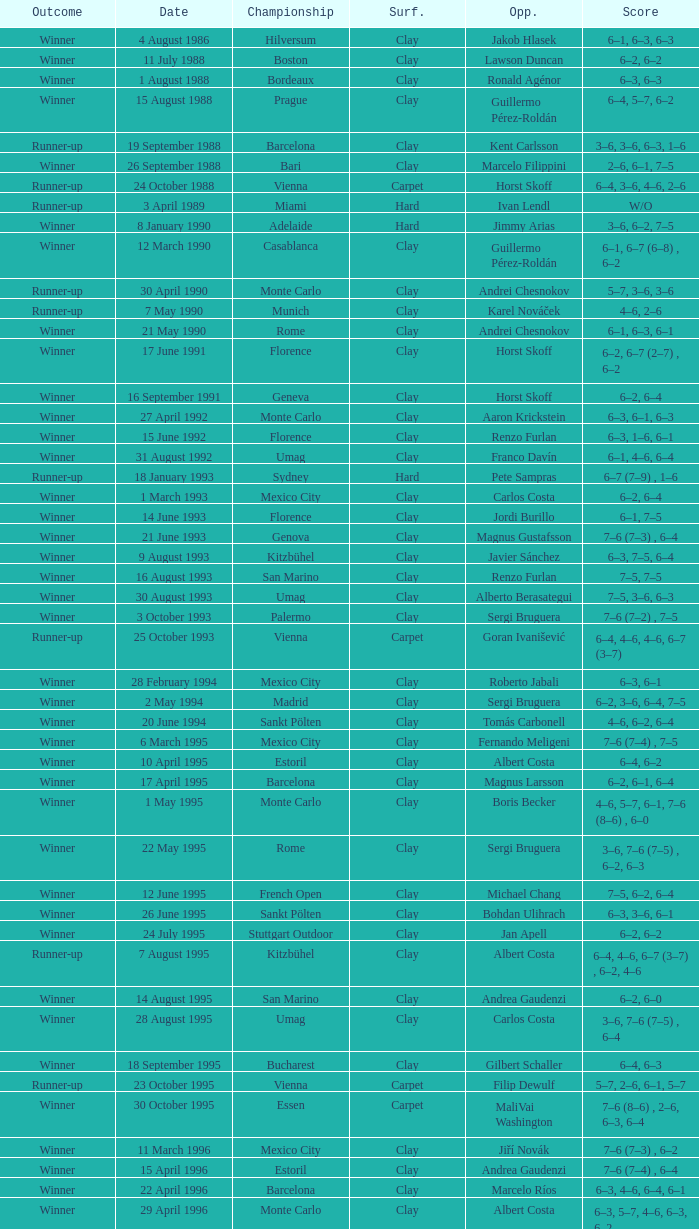Who was the adversary in the estoril championship on april 15, 1996, where the match was played on clay and resulted in a victory? Andrea Gaudenzi. 